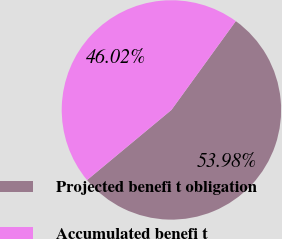Convert chart. <chart><loc_0><loc_0><loc_500><loc_500><pie_chart><fcel>Projected benefi t obligation<fcel>Accumulated benefi t<nl><fcel>53.98%<fcel>46.02%<nl></chart> 